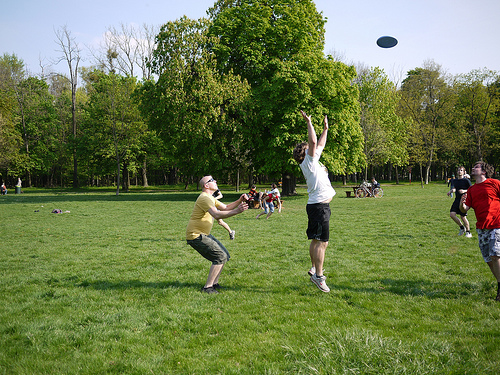What activity does the image portray? The image portrays people enjoying a game of frisbee in a park setting. Why do you think playing frisbee is a popular outdoor activity? Playing frisbee is a popular outdoor activity because it's easy to play, requires minimal equipment, and can be enjoyed by people of all ages. It also promotes physical exercise and allows people to enjoy the fresh air and natural surroundings. 